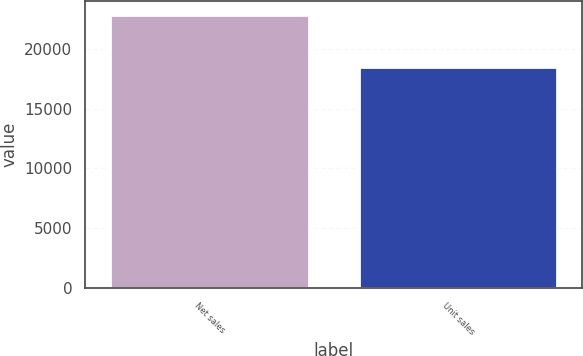Convert chart. <chart><loc_0><loc_0><loc_500><loc_500><bar_chart><fcel>Net sales<fcel>Unit sales<nl><fcel>22831<fcel>18484<nl></chart> 